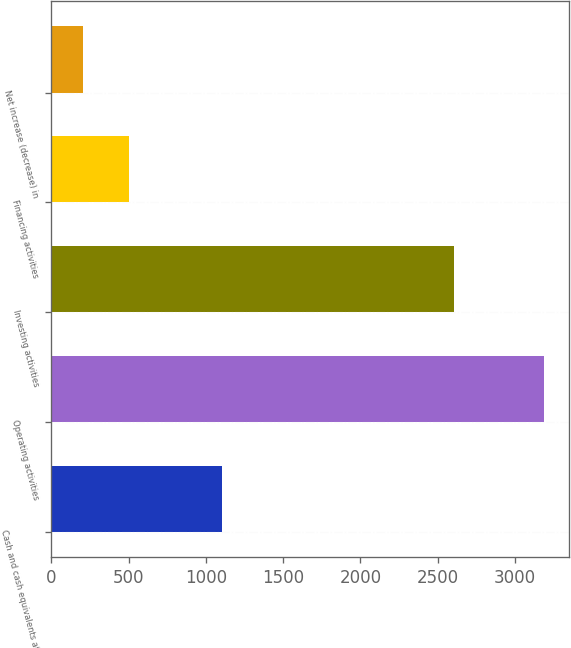Convert chart to OTSL. <chart><loc_0><loc_0><loc_500><loc_500><bar_chart><fcel>Cash and cash equivalents at<fcel>Operating activities<fcel>Investing activities<fcel>Financing activities<fcel>Net increase (decrease) in<nl><fcel>1100.9<fcel>3189<fcel>2602<fcel>504.3<fcel>206<nl></chart> 